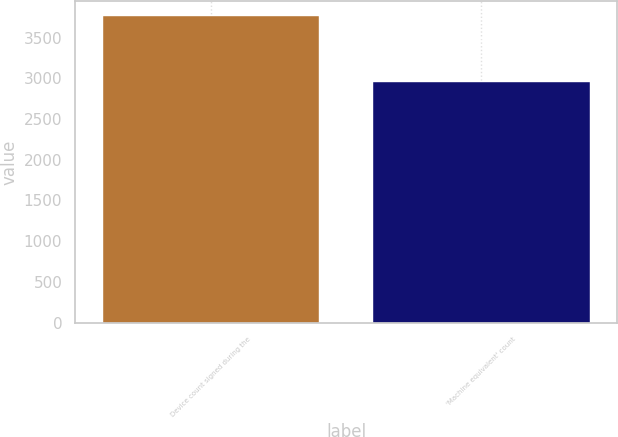Convert chart. <chart><loc_0><loc_0><loc_500><loc_500><bar_chart><fcel>Device count signed during the<fcel>'Machine equivalent' count<nl><fcel>3760<fcel>2951<nl></chart> 